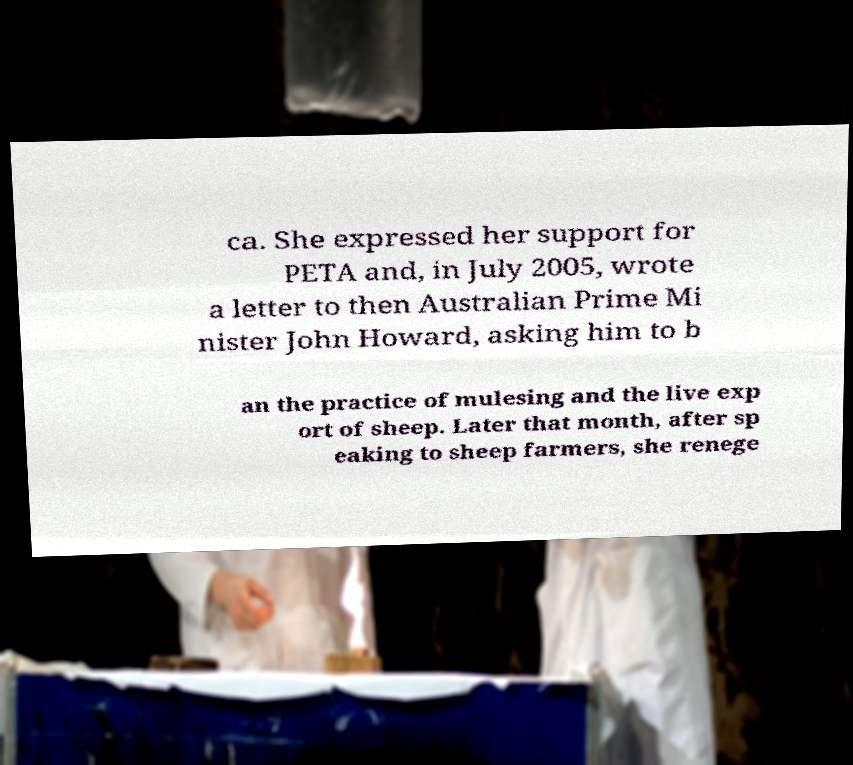Can you accurately transcribe the text from the provided image for me? ca. She expressed her support for PETA and, in July 2005, wrote a letter to then Australian Prime Mi nister John Howard, asking him to b an the practice of mulesing and the live exp ort of sheep. Later that month, after sp eaking to sheep farmers, she renege 